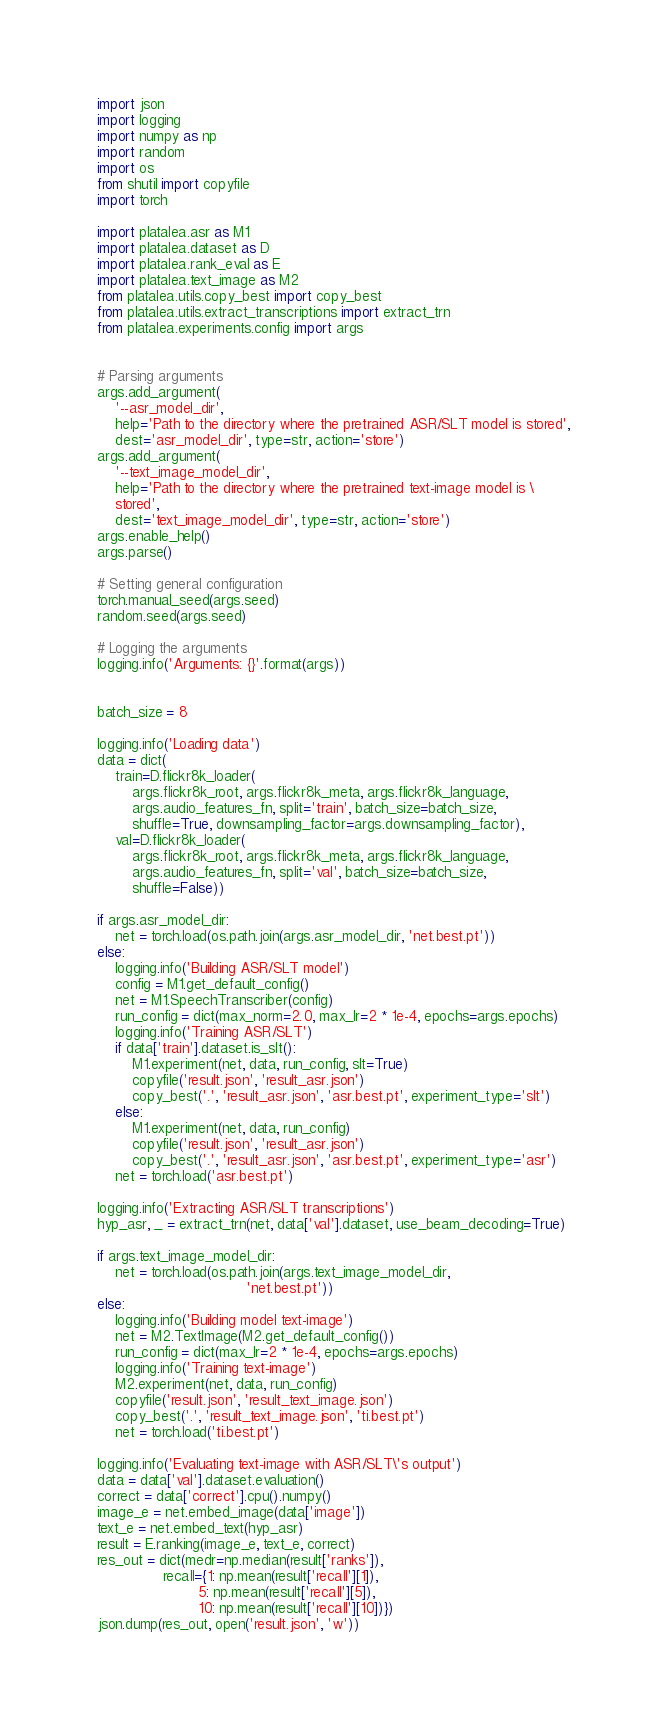<code> <loc_0><loc_0><loc_500><loc_500><_Python_>import json
import logging
import numpy as np
import random
import os
from shutil import copyfile
import torch

import platalea.asr as M1
import platalea.dataset as D
import platalea.rank_eval as E
import platalea.text_image as M2
from platalea.utils.copy_best import copy_best
from platalea.utils.extract_transcriptions import extract_trn
from platalea.experiments.config import args


# Parsing arguments
args.add_argument(
    '--asr_model_dir',
    help='Path to the directory where the pretrained ASR/SLT model is stored',
    dest='asr_model_dir', type=str, action='store')
args.add_argument(
    '--text_image_model_dir',
    help='Path to the directory where the pretrained text-image model is \
    stored',
    dest='text_image_model_dir', type=str, action='store')
args.enable_help()
args.parse()

# Setting general configuration
torch.manual_seed(args.seed)
random.seed(args.seed)

# Logging the arguments
logging.info('Arguments: {}'.format(args))


batch_size = 8

logging.info('Loading data')
data = dict(
    train=D.flickr8k_loader(
        args.flickr8k_root, args.flickr8k_meta, args.flickr8k_language,
        args.audio_features_fn, split='train', batch_size=batch_size,
        shuffle=True, downsampling_factor=args.downsampling_factor),
    val=D.flickr8k_loader(
        args.flickr8k_root, args.flickr8k_meta, args.flickr8k_language,
        args.audio_features_fn, split='val', batch_size=batch_size,
        shuffle=False))

if args.asr_model_dir:
    net = torch.load(os.path.join(args.asr_model_dir, 'net.best.pt'))
else:
    logging.info('Building ASR/SLT model')
    config = M1.get_default_config()
    net = M1.SpeechTranscriber(config)
    run_config = dict(max_norm=2.0, max_lr=2 * 1e-4, epochs=args.epochs)
    logging.info('Training ASR/SLT')
    if data['train'].dataset.is_slt():
        M1.experiment(net, data, run_config, slt=True)
        copyfile('result.json', 'result_asr.json')
        copy_best('.', 'result_asr.json', 'asr.best.pt', experiment_type='slt')
    else:
        M1.experiment(net, data, run_config)
        copyfile('result.json', 'result_asr.json')
        copy_best('.', 'result_asr.json', 'asr.best.pt', experiment_type='asr')
    net = torch.load('asr.best.pt')

logging.info('Extracting ASR/SLT transcriptions')
hyp_asr, _ = extract_trn(net, data['val'].dataset, use_beam_decoding=True)

if args.text_image_model_dir:
    net = torch.load(os.path.join(args.text_image_model_dir,
                                  'net.best.pt'))
else:
    logging.info('Building model text-image')
    net = M2.TextImage(M2.get_default_config())
    run_config = dict(max_lr=2 * 1e-4, epochs=args.epochs)
    logging.info('Training text-image')
    M2.experiment(net, data, run_config)
    copyfile('result.json', 'result_text_image.json')
    copy_best('.', 'result_text_image.json', 'ti.best.pt')
    net = torch.load('ti.best.pt')

logging.info('Evaluating text-image with ASR/SLT\'s output')
data = data['val'].dataset.evaluation()
correct = data['correct'].cpu().numpy()
image_e = net.embed_image(data['image'])
text_e = net.embed_text(hyp_asr)
result = E.ranking(image_e, text_e, correct)
res_out = dict(medr=np.median(result['ranks']),
               recall={1: np.mean(result['recall'][1]),
                       5: np.mean(result['recall'][5]),
                       10: np.mean(result['recall'][10])})
json.dump(res_out, open('result.json', 'w'))
</code> 